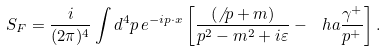Convert formula to latex. <formula><loc_0><loc_0><loc_500><loc_500>S _ { F } = \frac { i } { ( 2 \pi ) ^ { 4 } } \int d ^ { 4 } p \, e ^ { - i p \cdot x } \left [ \frac { ( \not \, { p } + m ) } { p ^ { 2 } - m ^ { 2 } + i \varepsilon } - \ h a \frac { \gamma ^ { + } } { p ^ { + } } \right ] .</formula> 